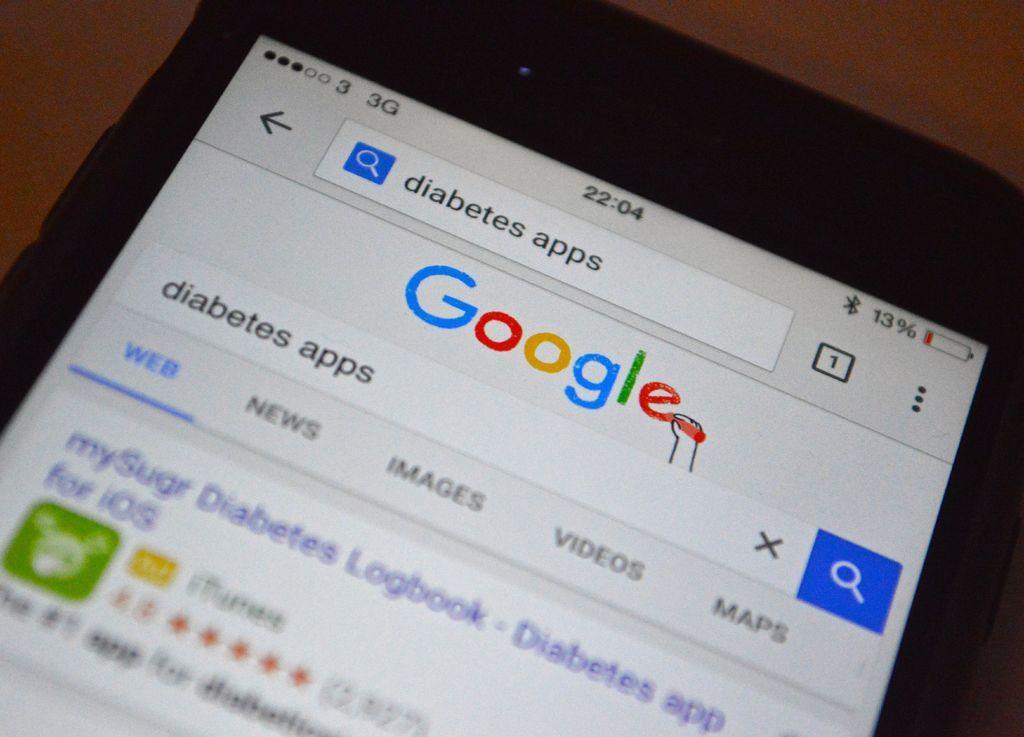In one or two sentences, can you explain what this image depicts? In this image we can see a display screen. 